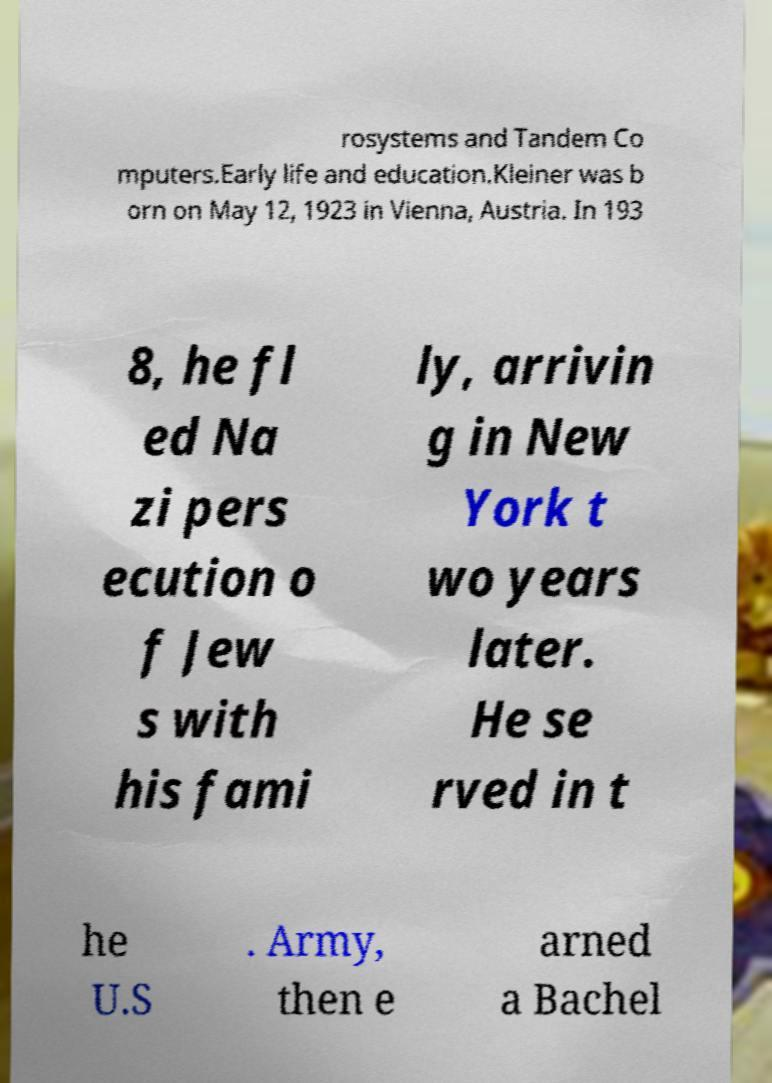What messages or text are displayed in this image? I need them in a readable, typed format. rosystems and Tandem Co mputers.Early life and education.Kleiner was b orn on May 12, 1923 in Vienna, Austria. In 193 8, he fl ed Na zi pers ecution o f Jew s with his fami ly, arrivin g in New York t wo years later. He se rved in t he U.S . Army, then e arned a Bachel 